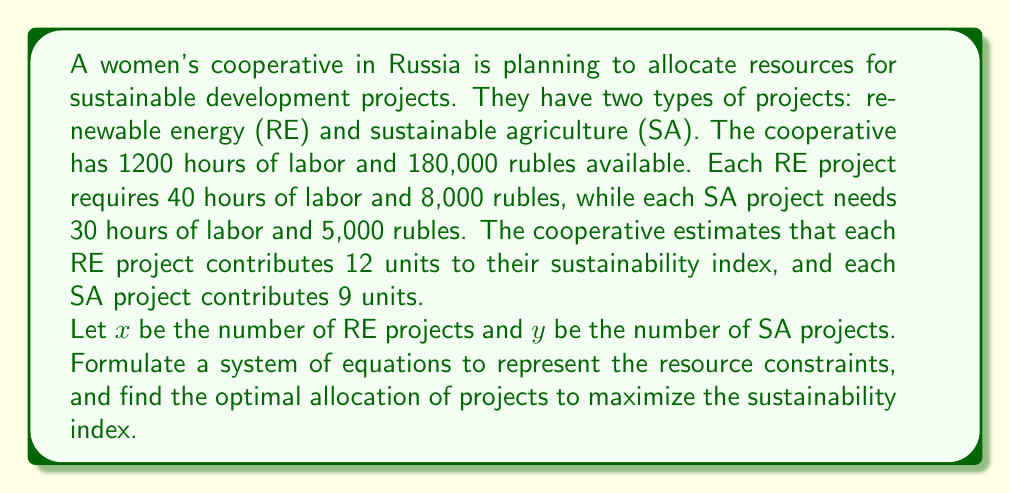Solve this math problem. Let's approach this problem step by step:

1. Formulate the system of equations:
   - Labor constraint: $40x + 30y \leq 1200$
   - Financial constraint: $8000x + 5000y \leq 180000$

2. Simplify the equations:
   - $40x + 30y \leq 1200$
   - $8x + 5y \leq 180$

3. The sustainability index (SI) to be maximized is:
   $SI = 12x + 9y$

4. To find the optimal solution, we need to solve the system of equations:
   $$\begin{cases}
   40x + 30y = 1200 \\
   8x + 5y = 180
   \end{cases}$$

5. Multiply the second equation by 5:
   $$\begin{cases}
   40x + 30y = 1200 \\
   40x + 25y = 900
   \end{cases}$$

6. Subtract the second equation from the first:
   $5y = 300$
   $y = 60$

7. Substitute $y = 60$ into $8x + 5y = 180$:
   $8x + 5(60) = 180$
   $8x + 300 = 180$
   $8x = -120$
   $x = -15$

8. However, $x$ cannot be negative. This means we need to find the integer solution that satisfies both constraints and maximizes the sustainability index.

9. Let's check the corner points:
   (0, 60): SI = 0 + 9(60) = 540
   (22, 0): SI = 12(22) + 0 = 264
   (15, 20): SI = 12(15) + 9(20) = 360

10. The optimal integer solution is (15, 20), which gives the maximum sustainability index of 360.
Answer: The optimal allocation is 15 renewable energy projects and 20 sustainable agriculture projects, resulting in a maximum sustainability index of 360. 